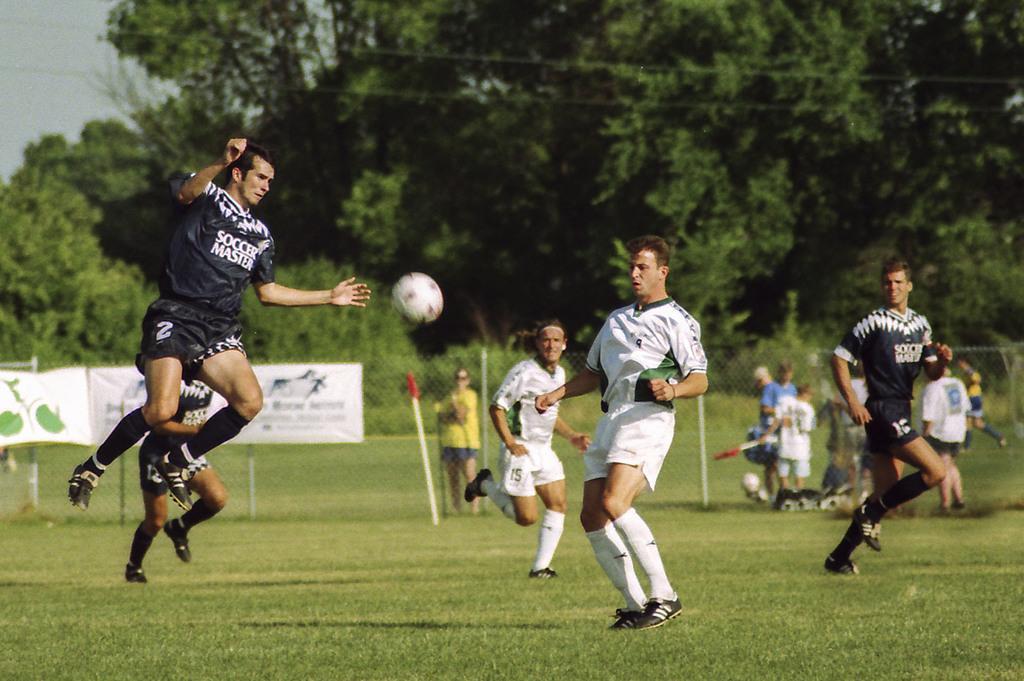Describe this image in one or two sentences. In this picture I can see few players playing foot ball and I can see trees and couple of banners with some text and I can see grass on the ground and I can see a man jumping and I can see a cloudy sky. 